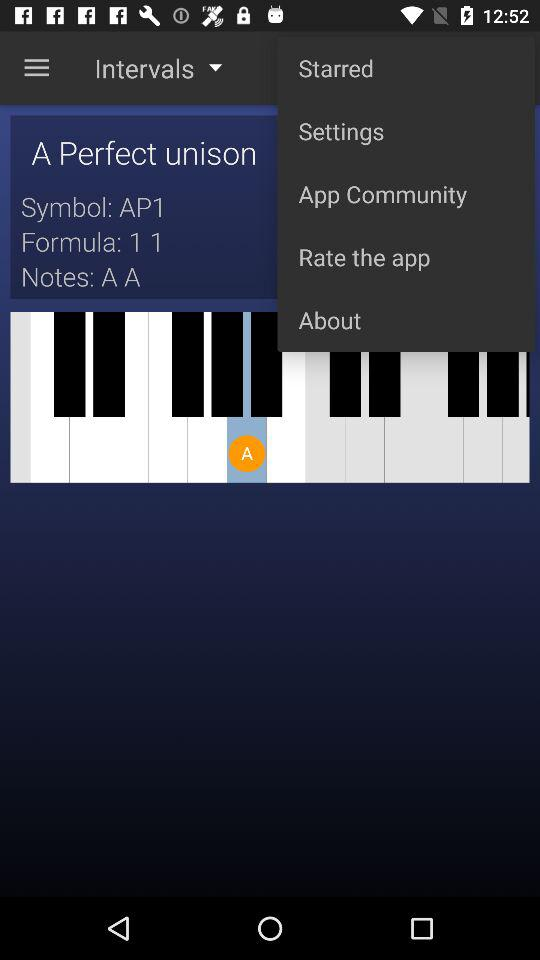What is the given formula? The given formula is 1 1. 